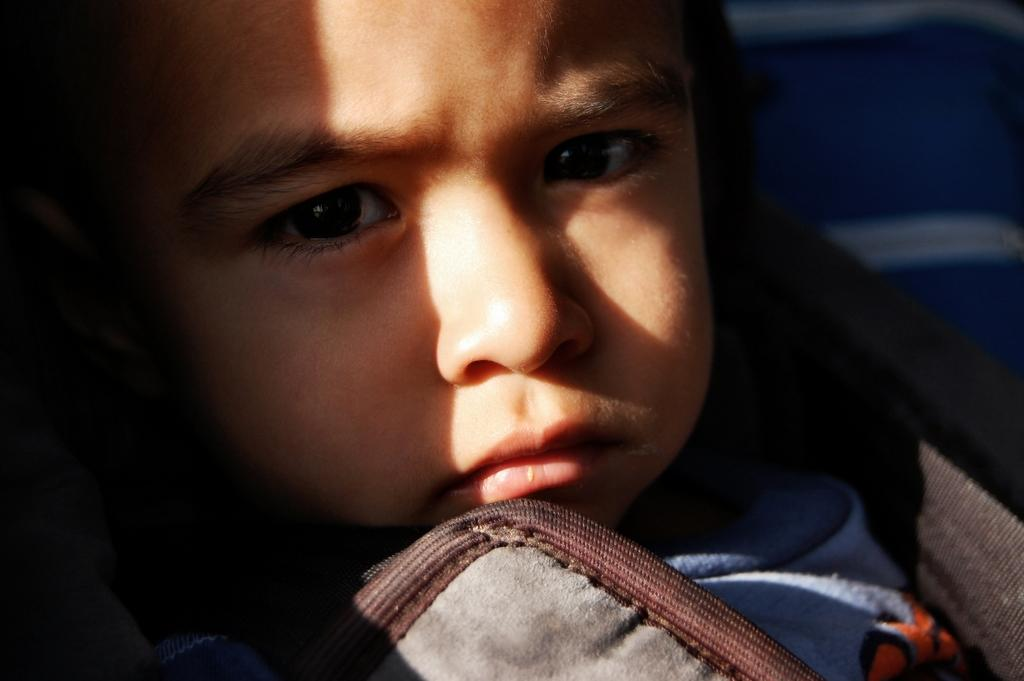What is the main subject of the image? The main subject of the image is a kid. What type of fish can be seen swimming in the cellar in the image? There is no fish or cellar present in the image; it features a kid. What is the texture of the kid's clothing in the image? The provided facts do not mention the texture of the kid's clothing, so it cannot be determined from the image. 